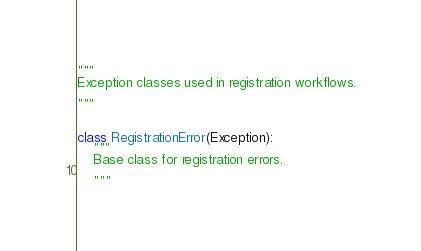<code> <loc_0><loc_0><loc_500><loc_500><_Python_>"""
Exception classes used in registration workflows.

"""


class RegistrationError(Exception):
    """
    Base class for registration errors.

    """
</code> 